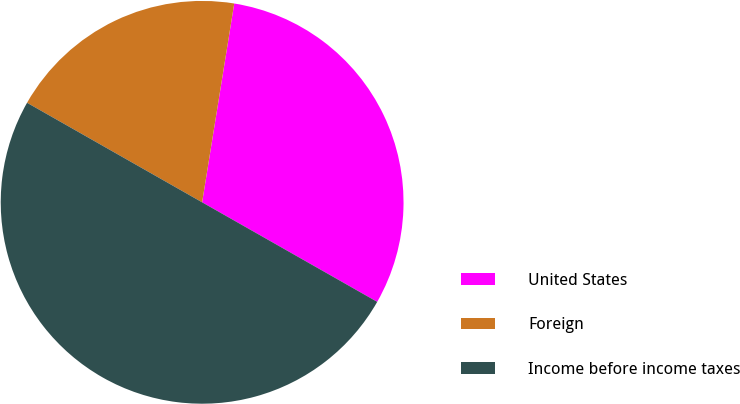Convert chart. <chart><loc_0><loc_0><loc_500><loc_500><pie_chart><fcel>United States<fcel>Foreign<fcel>Income before income taxes<nl><fcel>30.68%<fcel>19.32%<fcel>50.0%<nl></chart> 